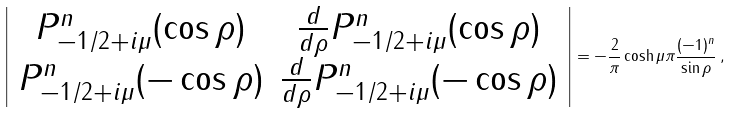Convert formula to latex. <formula><loc_0><loc_0><loc_500><loc_500>\left | \begin{array} { c c } P ^ { n } _ { - 1 / 2 + i \mu } ( \cos \rho ) & \frac { d } { d \rho } P ^ { n } _ { - 1 / 2 + i \mu } ( \cos \rho ) \\ P ^ { n } _ { - 1 / 2 + i \mu } ( - \cos \rho ) & \frac { d } { d \rho } P ^ { n } _ { - 1 / 2 + i \mu } ( - \cos \rho ) \end{array} \right | = - \frac { 2 } { \pi } \cosh \mu \pi \frac { ( - 1 ) ^ { n } } { \sin \rho } \, ,</formula> 